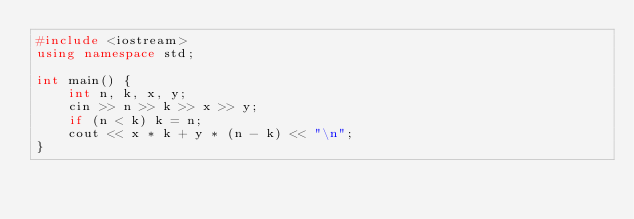<code> <loc_0><loc_0><loc_500><loc_500><_C++_>#include <iostream>
using namespace std;

int main() {
    int n, k, x, y;
    cin >> n >> k >> x >> y;
    if (n < k) k = n;
    cout << x * k + y * (n - k) << "\n";
}</code> 